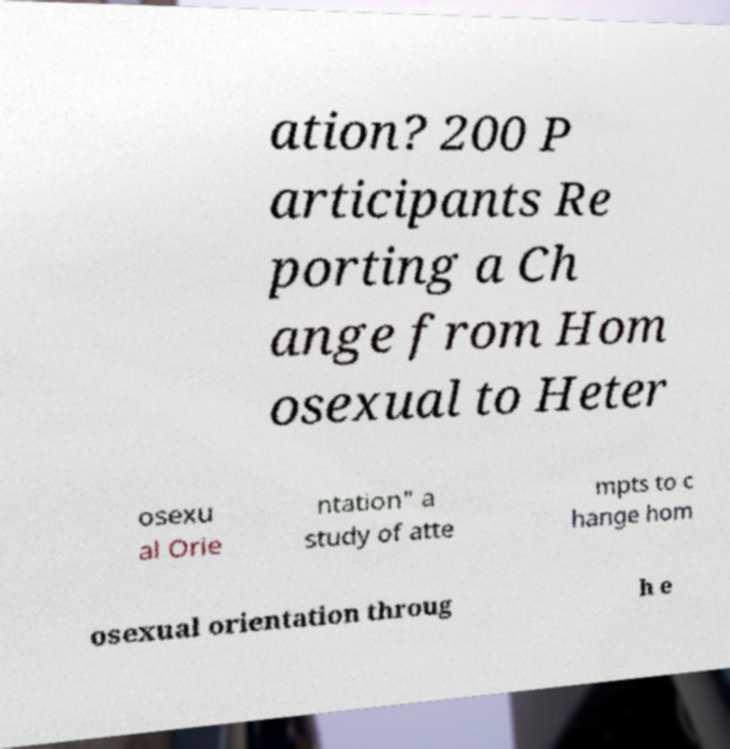Could you extract and type out the text from this image? ation? 200 P articipants Re porting a Ch ange from Hom osexual to Heter osexu al Orie ntation" a study of atte mpts to c hange hom osexual orientation throug h e 